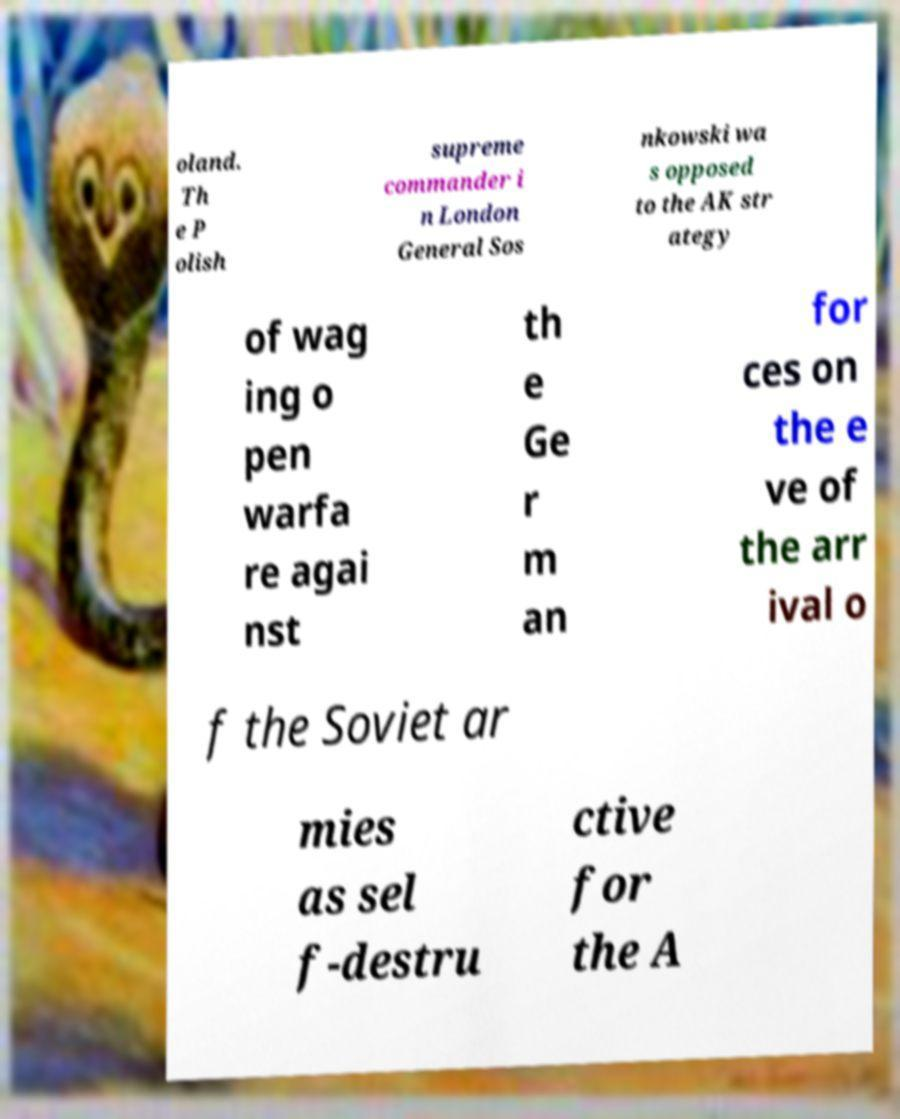Please read and relay the text visible in this image. What does it say? oland. Th e P olish supreme commander i n London General Sos nkowski wa s opposed to the AK str ategy of wag ing o pen warfa re agai nst th e Ge r m an for ces on the e ve of the arr ival o f the Soviet ar mies as sel f-destru ctive for the A 